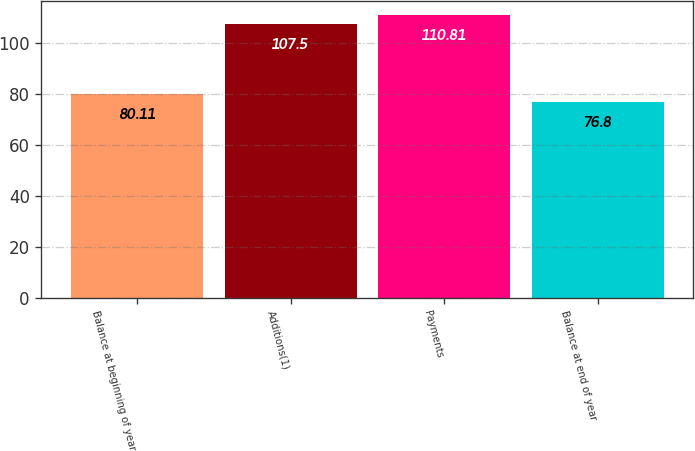<chart> <loc_0><loc_0><loc_500><loc_500><bar_chart><fcel>Balance at beginning of year<fcel>Additions(1)<fcel>Payments<fcel>Balance at end of year<nl><fcel>80.11<fcel>107.5<fcel>110.81<fcel>76.8<nl></chart> 